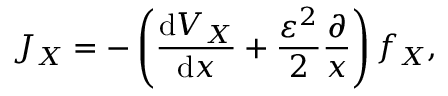Convert formula to latex. <formula><loc_0><loc_0><loc_500><loc_500>J _ { X } = - \left ( \frac { d V _ { X } } { d x } + \frac { \varepsilon ^ { 2 } } { 2 } \frac { \partial } { x } \right ) f _ { X } ,</formula> 